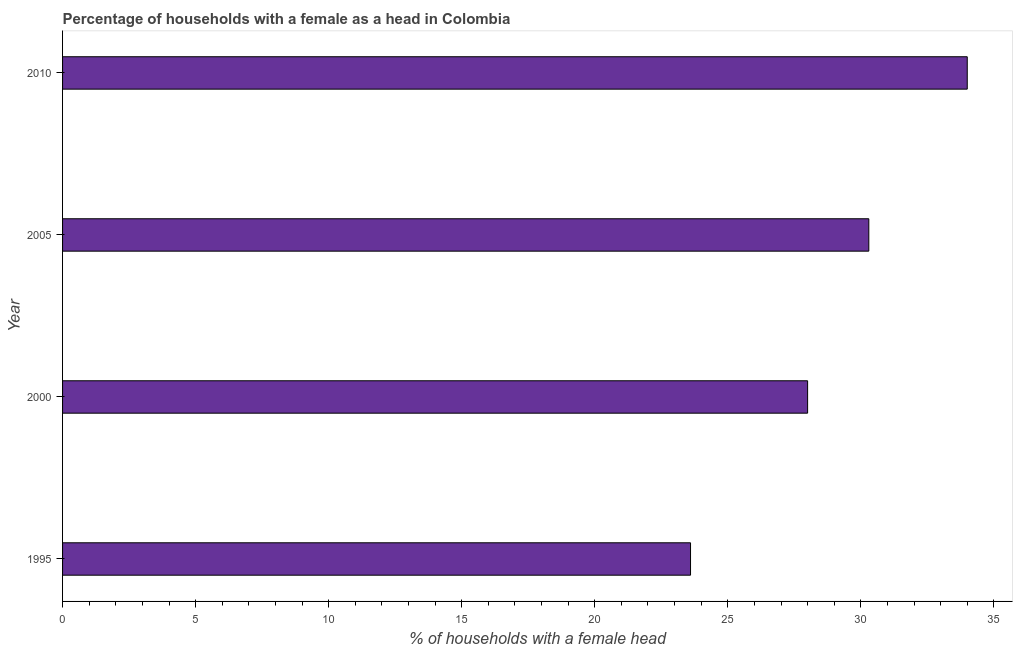What is the title of the graph?
Keep it short and to the point. Percentage of households with a female as a head in Colombia. What is the label or title of the X-axis?
Offer a very short reply. % of households with a female head. What is the label or title of the Y-axis?
Keep it short and to the point. Year. What is the number of female supervised households in 2005?
Your answer should be very brief. 30.3. Across all years, what is the maximum number of female supervised households?
Provide a succinct answer. 34. Across all years, what is the minimum number of female supervised households?
Offer a very short reply. 23.6. In which year was the number of female supervised households minimum?
Provide a short and direct response. 1995. What is the sum of the number of female supervised households?
Offer a very short reply. 115.9. What is the average number of female supervised households per year?
Offer a terse response. 28.98. What is the median number of female supervised households?
Your answer should be compact. 29.15. In how many years, is the number of female supervised households greater than 4 %?
Your response must be concise. 4. Do a majority of the years between 1995 and 2010 (inclusive) have number of female supervised households greater than 31 %?
Your answer should be compact. No. What is the ratio of the number of female supervised households in 2005 to that in 2010?
Offer a very short reply. 0.89. Is the number of female supervised households in 1995 less than that in 2005?
Provide a succinct answer. Yes. In how many years, is the number of female supervised households greater than the average number of female supervised households taken over all years?
Offer a very short reply. 2. How many bars are there?
Your response must be concise. 4. What is the difference between two consecutive major ticks on the X-axis?
Your response must be concise. 5. Are the values on the major ticks of X-axis written in scientific E-notation?
Offer a terse response. No. What is the % of households with a female head in 1995?
Ensure brevity in your answer.  23.6. What is the % of households with a female head of 2000?
Keep it short and to the point. 28. What is the % of households with a female head of 2005?
Offer a terse response. 30.3. What is the difference between the % of households with a female head in 1995 and 2005?
Give a very brief answer. -6.7. What is the difference between the % of households with a female head in 1995 and 2010?
Provide a succinct answer. -10.4. What is the difference between the % of households with a female head in 2000 and 2005?
Offer a terse response. -2.3. What is the difference between the % of households with a female head in 2000 and 2010?
Make the answer very short. -6. What is the ratio of the % of households with a female head in 1995 to that in 2000?
Give a very brief answer. 0.84. What is the ratio of the % of households with a female head in 1995 to that in 2005?
Provide a short and direct response. 0.78. What is the ratio of the % of households with a female head in 1995 to that in 2010?
Provide a succinct answer. 0.69. What is the ratio of the % of households with a female head in 2000 to that in 2005?
Offer a very short reply. 0.92. What is the ratio of the % of households with a female head in 2000 to that in 2010?
Provide a short and direct response. 0.82. What is the ratio of the % of households with a female head in 2005 to that in 2010?
Keep it short and to the point. 0.89. 